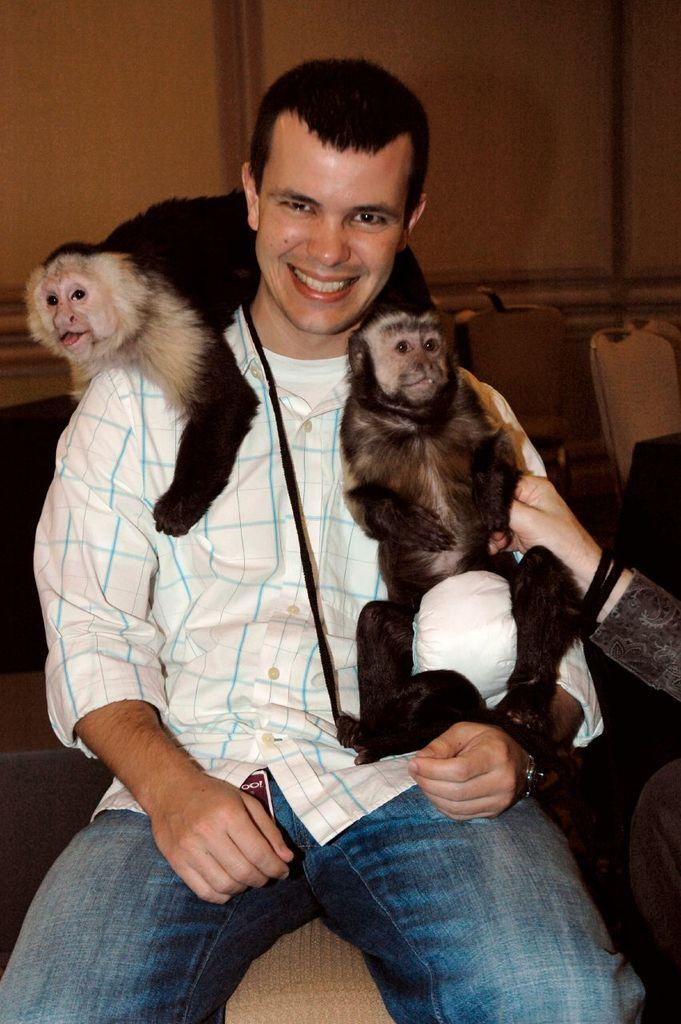What is the man in the image doing? The man is sitting in the chair. Are there any animals present in the image? Yes, there are two monkeys on the man. What can be seen in the background of the image? There is a wall in the background of the image. What color is the balloon that the man is holding in the image? There is no balloon present in the image. How does the man's hearing affect his interaction with the monkeys in the image? The man's hearing is not mentioned in the image, so it cannot be determined how it affects his interaction with the monkeys. 